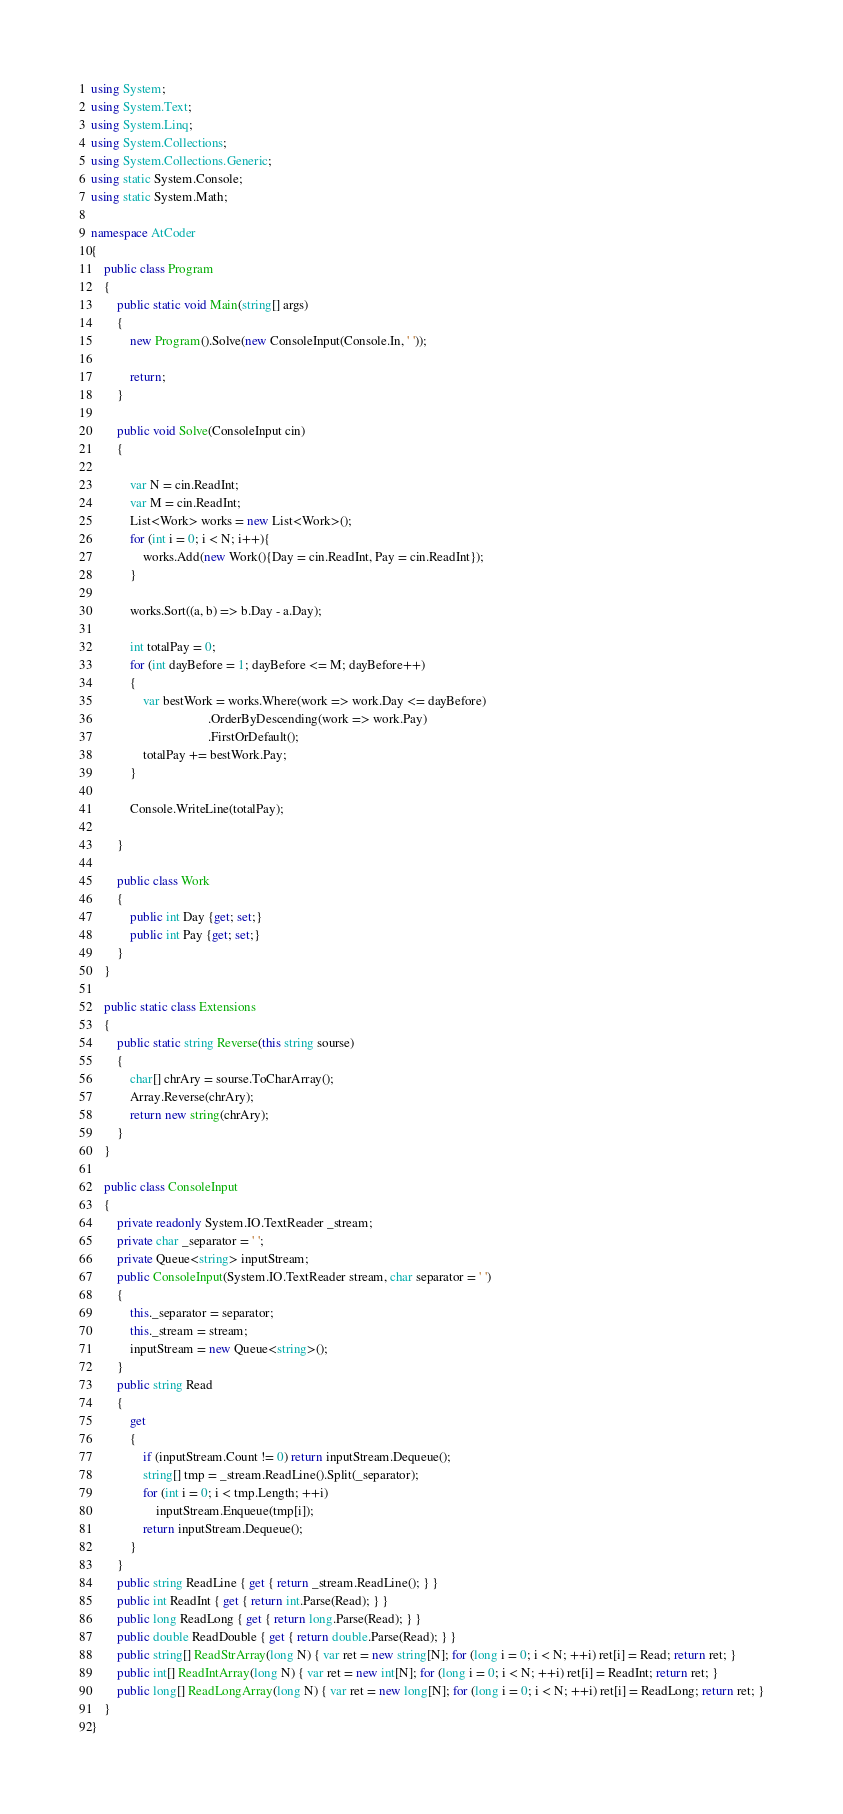Convert code to text. <code><loc_0><loc_0><loc_500><loc_500><_C#_>using System;
using System.Text;
using System.Linq;
using System.Collections;
using System.Collections.Generic;
using static System.Console;
using static System.Math;

namespace AtCoder
{
    public class Program
    {
        public static void Main(string[] args)
        {
            new Program().Solve(new ConsoleInput(Console.In, ' '));

            return;
        }

        public void Solve(ConsoleInput cin)
        {

            var N = cin.ReadInt;
            var M = cin.ReadInt;
            List<Work> works = new List<Work>();
            for (int i = 0; i < N; i++){
                works.Add(new Work(){Day = cin.ReadInt, Pay = cin.ReadInt});
            }

            works.Sort((a, b) => b.Day - a.Day);

            int totalPay = 0;
            for (int dayBefore = 1; dayBefore <= M; dayBefore++)
            {
                var bestWork = works.Where(work => work.Day <= dayBefore)
                                    .OrderByDescending(work => work.Pay)
                                    .FirstOrDefault();
                totalPay += bestWork.Pay;
            }

            Console.WriteLine(totalPay);

        }

        public class Work
        {
            public int Day {get; set;}
            public int Pay {get; set;}
        }
    }

    public static class Extensions
    {
        public static string Reverse(this string sourse)
        {
            char[] chrAry = sourse.ToCharArray();
            Array.Reverse(chrAry);
            return new string(chrAry);
        }
    }

    public class ConsoleInput
    {
        private readonly System.IO.TextReader _stream;
        private char _separator = ' ';
        private Queue<string> inputStream;
        public ConsoleInput(System.IO.TextReader stream, char separator = ' ')
        {
            this._separator = separator;
            this._stream = stream;
            inputStream = new Queue<string>();
        }
        public string Read
        {
            get
            {
                if (inputStream.Count != 0) return inputStream.Dequeue();
                string[] tmp = _stream.ReadLine().Split(_separator);
                for (int i = 0; i < tmp.Length; ++i)
                    inputStream.Enqueue(tmp[i]);
                return inputStream.Dequeue();
            }
        }
        public string ReadLine { get { return _stream.ReadLine(); } }
        public int ReadInt { get { return int.Parse(Read); } }
        public long ReadLong { get { return long.Parse(Read); } }
        public double ReadDouble { get { return double.Parse(Read); } }
        public string[] ReadStrArray(long N) { var ret = new string[N]; for (long i = 0; i < N; ++i) ret[i] = Read; return ret; }
        public int[] ReadIntArray(long N) { var ret = new int[N]; for (long i = 0; i < N; ++i) ret[i] = ReadInt; return ret; }
        public long[] ReadLongArray(long N) { var ret = new long[N]; for (long i = 0; i < N; ++i) ret[i] = ReadLong; return ret; }
    }
}
</code> 